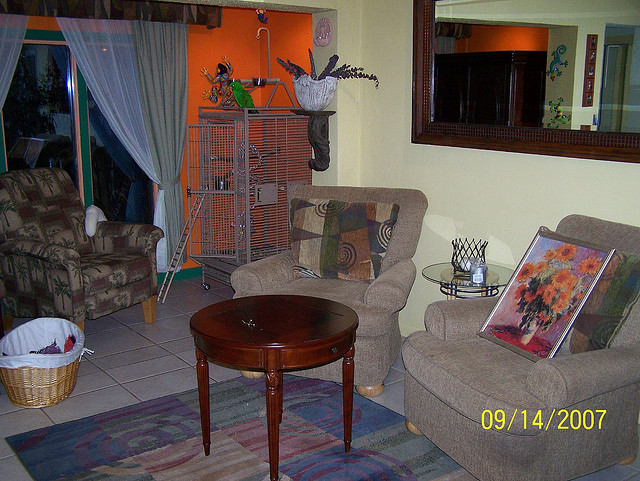Read and extract the text from this image. 09/14/2007 